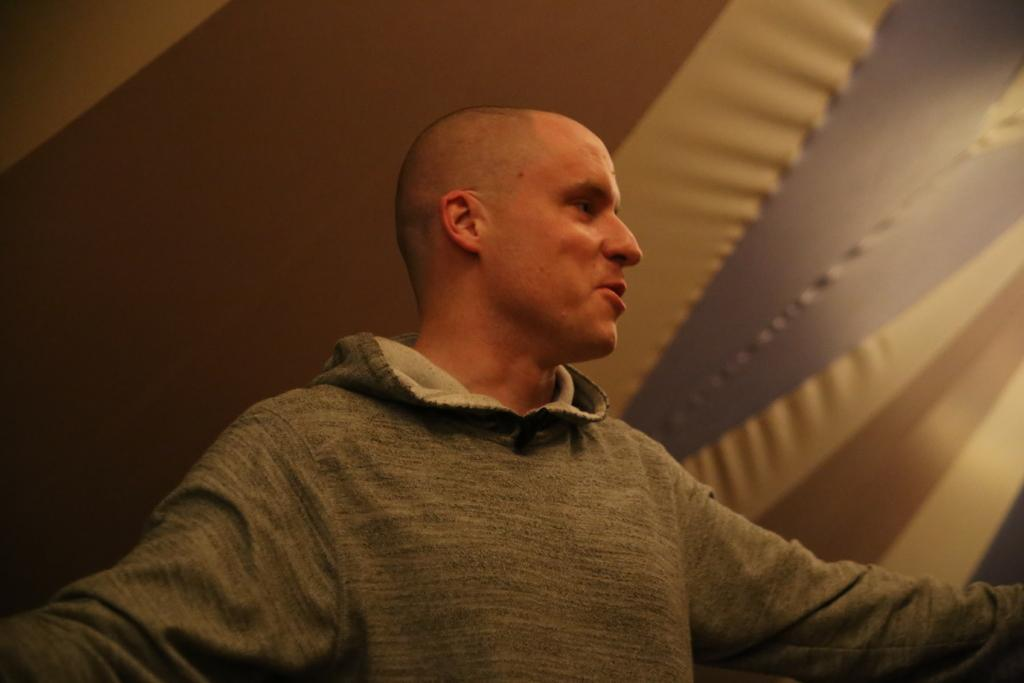Who is present in the image? There is a man in the image. Where is the man located? The man is standing in a room. What type of coil is the man holding in the image? There is no coil present in the image; the man is simply standing in a room. 